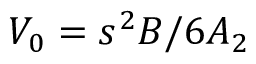<formula> <loc_0><loc_0><loc_500><loc_500>V _ { 0 } = s ^ { 2 } B / { 6 A _ { 2 } }</formula> 